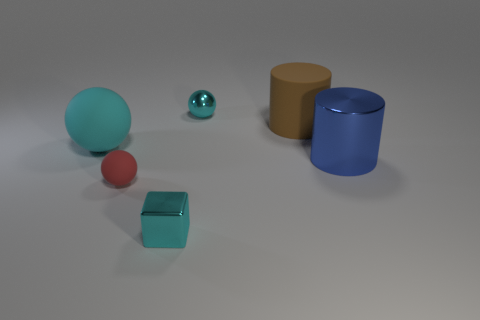How many things are either tiny blue cubes or metal things?
Offer a terse response. 3. There is a red rubber object; is it the same size as the cylinder that is on the right side of the large brown matte thing?
Offer a very short reply. No. There is a cyan metal thing behind the cyan metal thing that is in front of the big cylinder on the left side of the big blue shiny object; what size is it?
Give a very brief answer. Small. Is there a large cyan sphere?
Ensure brevity in your answer.  Yes. What is the material of the large thing that is the same color as the small block?
Give a very brief answer. Rubber. What number of tiny shiny spheres have the same color as the shiny block?
Your response must be concise. 1. How many things are either small cyan things in front of the large blue metal object or cyan metallic objects that are in front of the small cyan metallic ball?
Provide a short and direct response. 1. What number of tiny matte spheres are on the right side of the tiny cyan block in front of the large cyan sphere?
Keep it short and to the point. 0. There is another big object that is the same material as the brown object; what is its color?
Offer a very short reply. Cyan. Is there a blue thing that has the same size as the cyan metal cube?
Provide a short and direct response. No. 